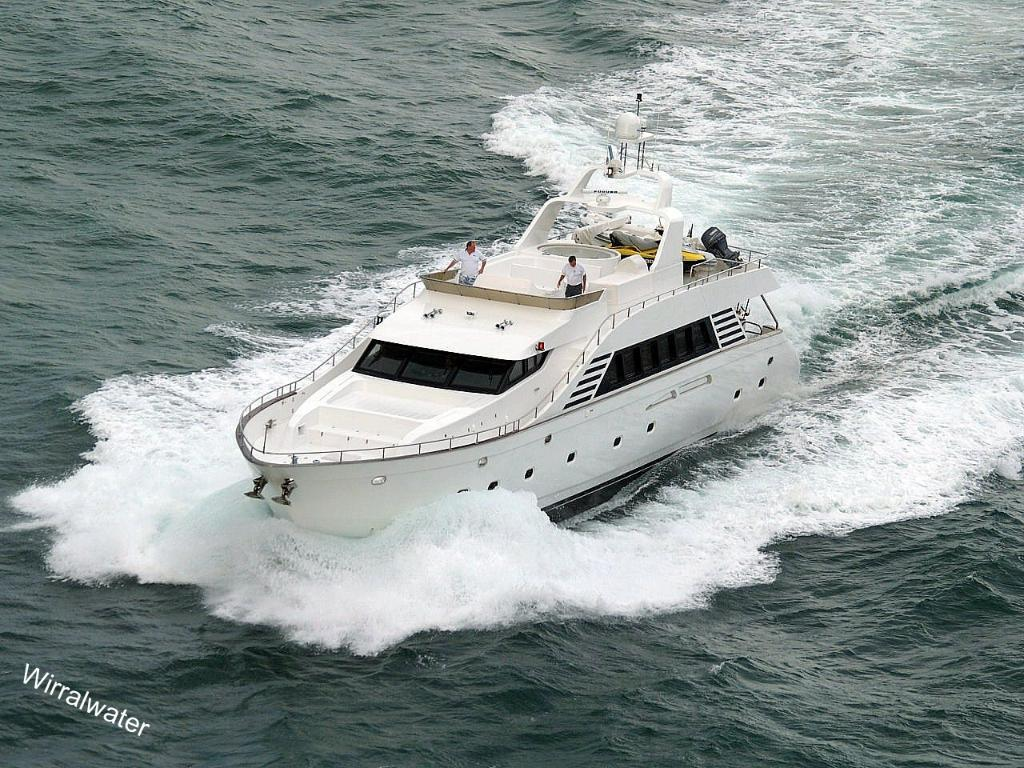How many people are on the ship in the image? There are two people standing on the ship in the image. What is the ship's location in relation to the water? The ship is on the water in the image. Is there any additional information about the image itself? Yes, there is a watermark on the image. What type of bubble is being used by the people on the ship in the image? There is no bubble present in the image; the people are standing on a ship on the water. What substance is being processed by the people on the ship in the image? There is no indication in the image that the people are processing any substance. 